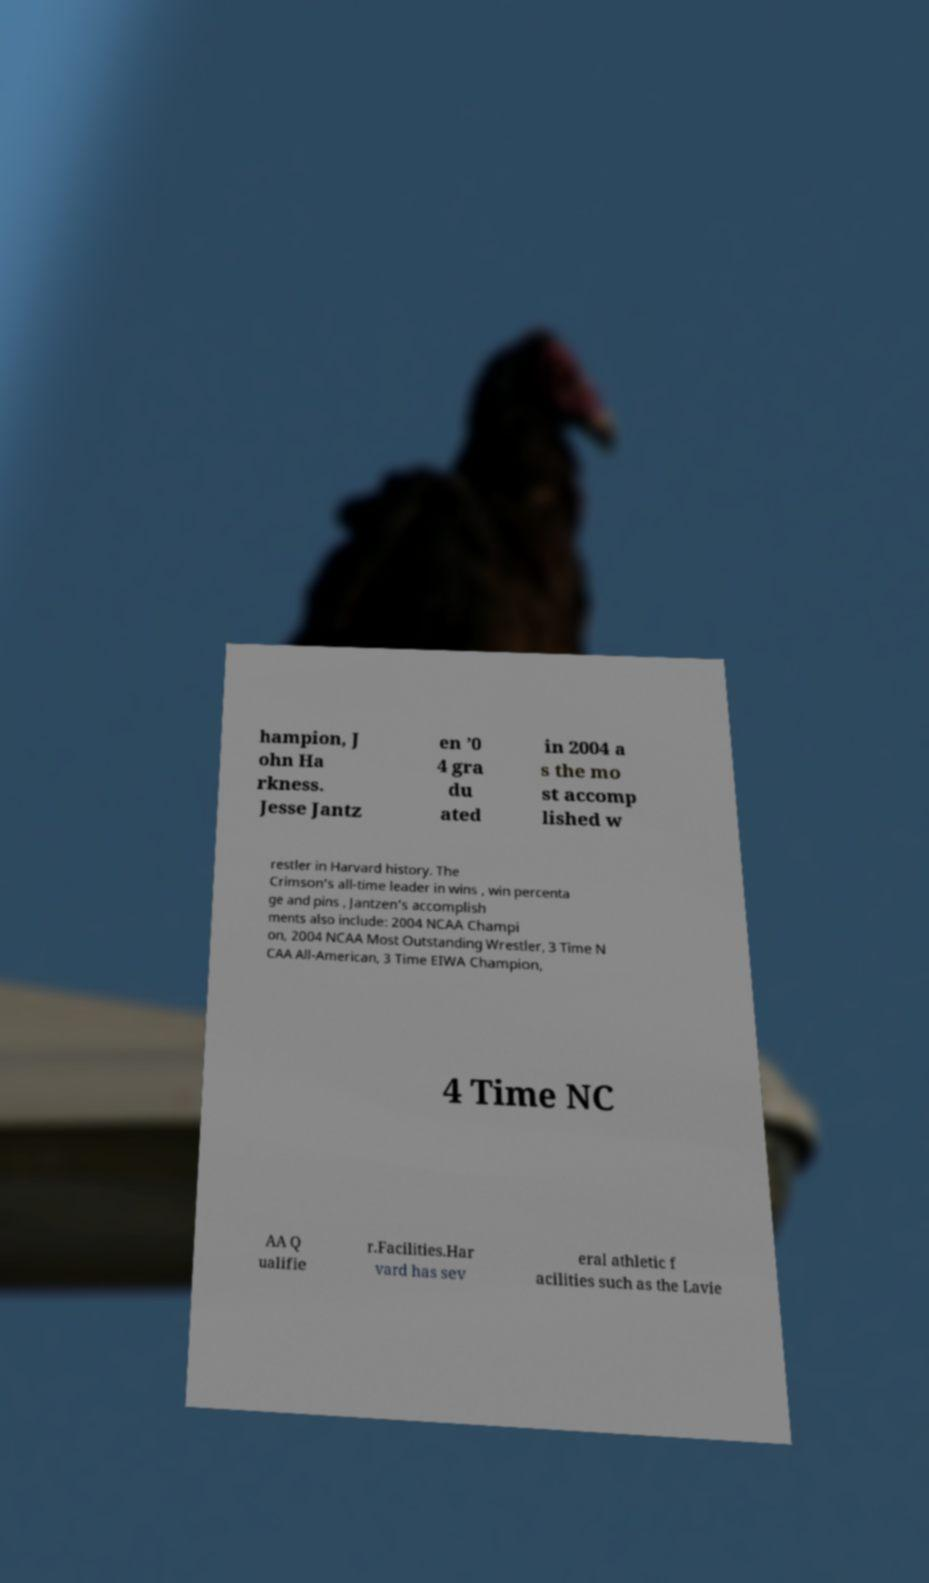Please identify and transcribe the text found in this image. hampion, J ohn Ha rkness. Jesse Jantz en ’0 4 gra du ated in 2004 a s the mo st accomp lished w restler in Harvard history. The Crimson’s all-time leader in wins , win percenta ge and pins , Jantzen’s accomplish ments also include: 2004 NCAA Champi on, 2004 NCAA Most Outstanding Wrestler, 3 Time N CAA All-American, 3 Time EIWA Champion, 4 Time NC AA Q ualifie r.Facilities.Har vard has sev eral athletic f acilities such as the Lavie 